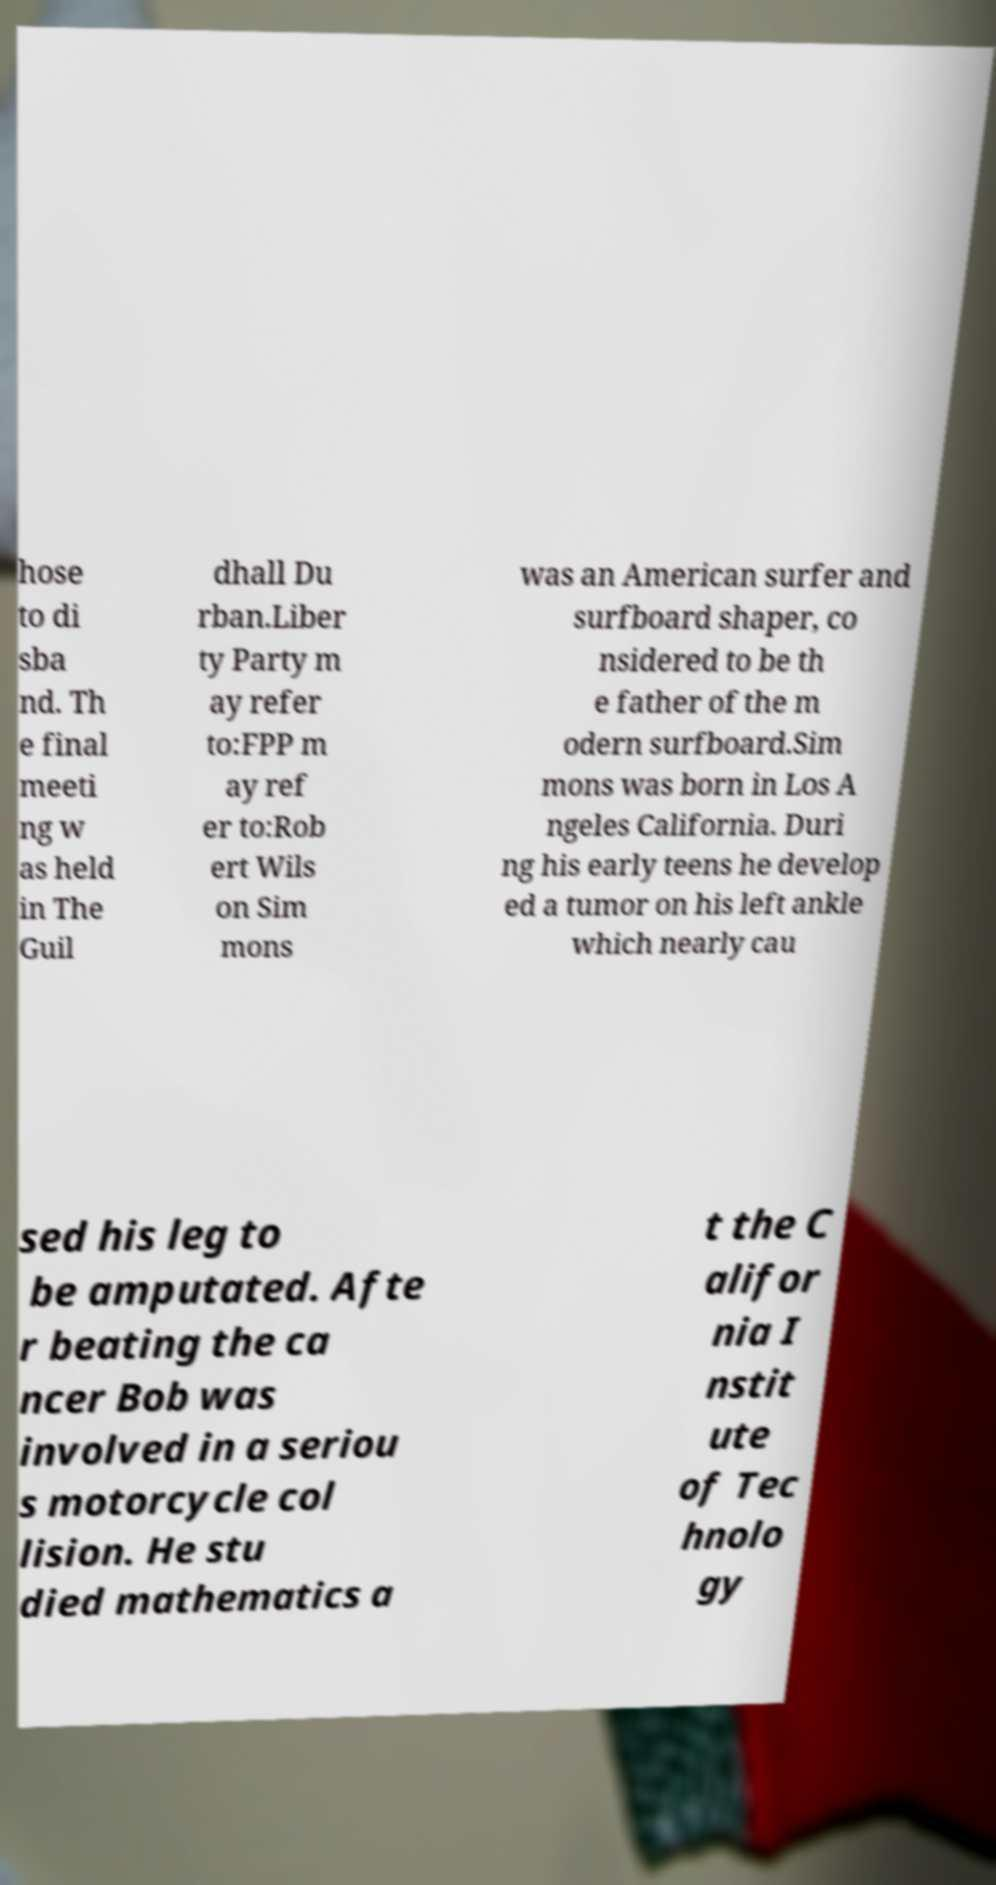There's text embedded in this image that I need extracted. Can you transcribe it verbatim? hose to di sba nd. Th e final meeti ng w as held in The Guil dhall Du rban.Liber ty Party m ay refer to:FPP m ay ref er to:Rob ert Wils on Sim mons was an American surfer and surfboard shaper, co nsidered to be th e father of the m odern surfboard.Sim mons was born in Los A ngeles California. Duri ng his early teens he develop ed a tumor on his left ankle which nearly cau sed his leg to be amputated. Afte r beating the ca ncer Bob was involved in a seriou s motorcycle col lision. He stu died mathematics a t the C alifor nia I nstit ute of Tec hnolo gy 